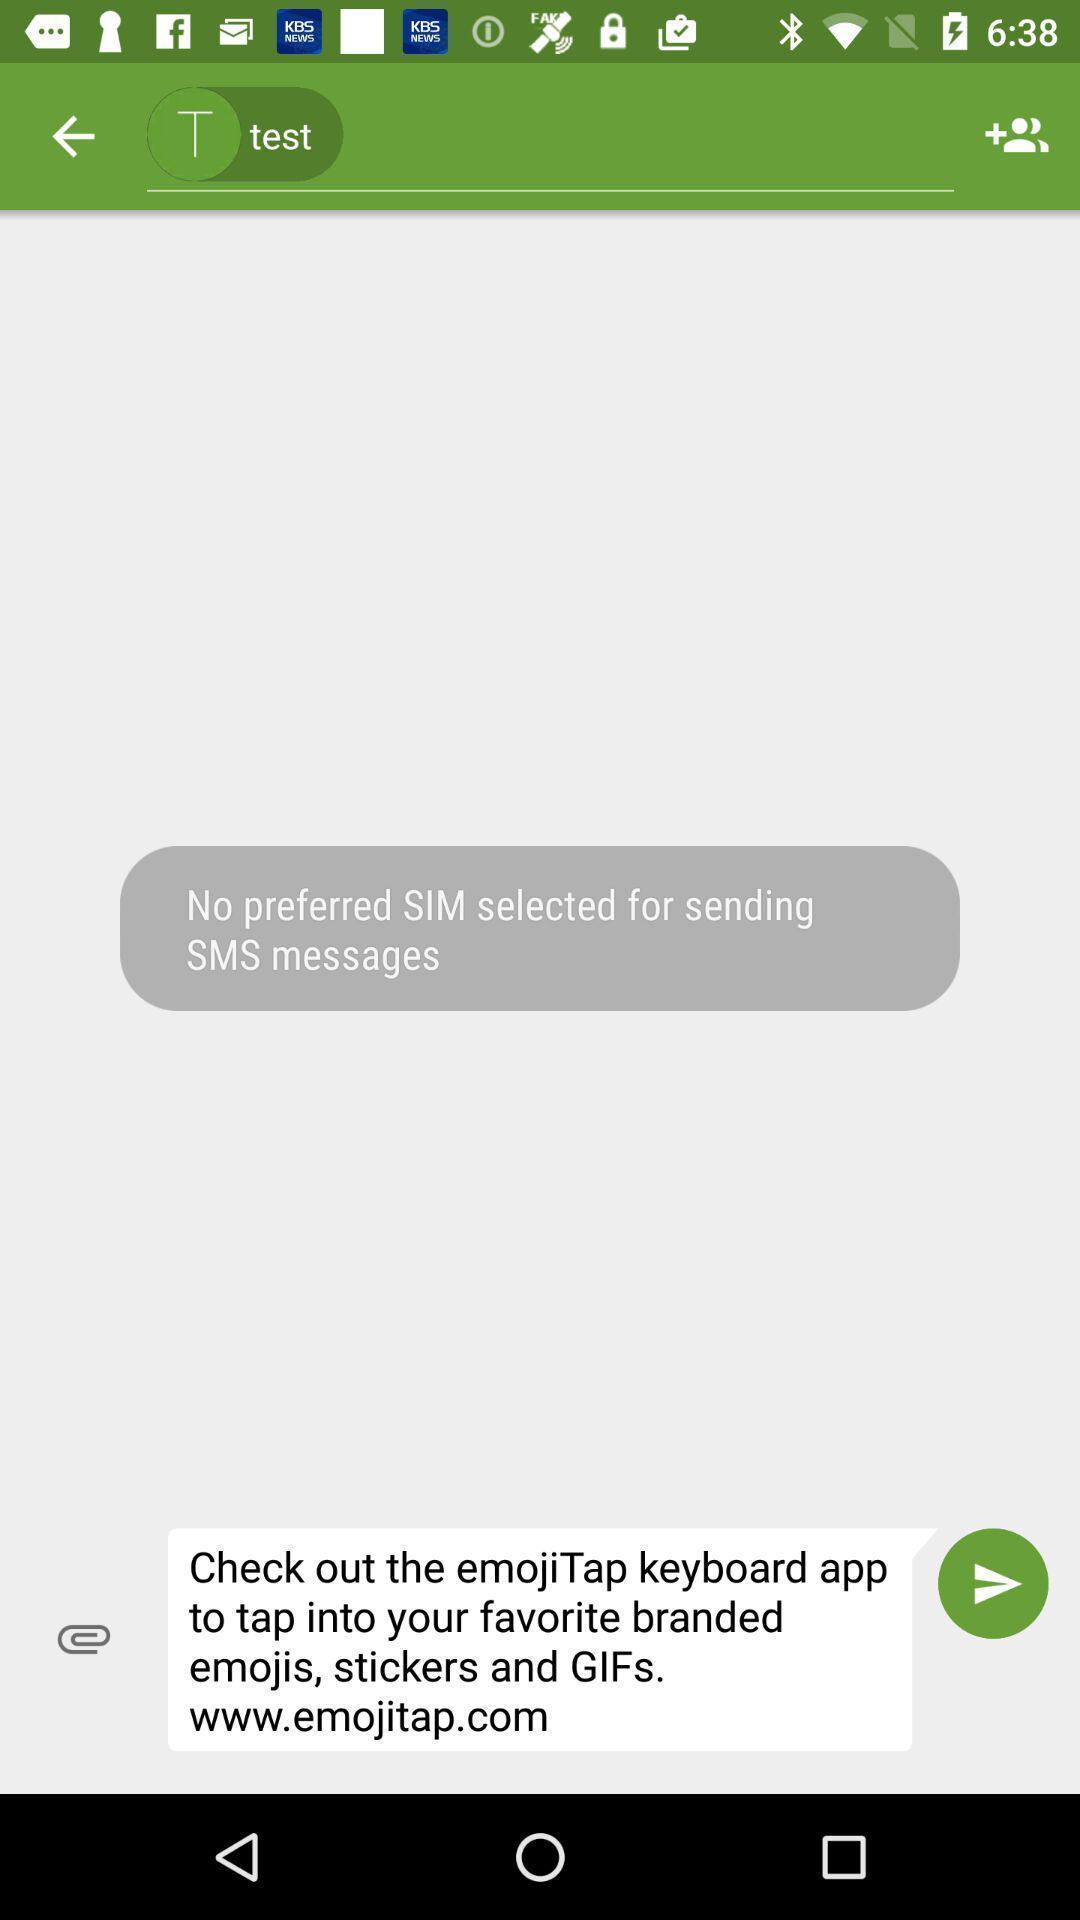What details can you identify in this image? Page displaying to send data in app. 